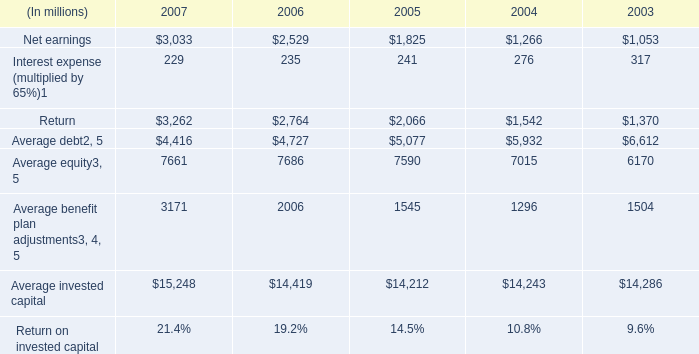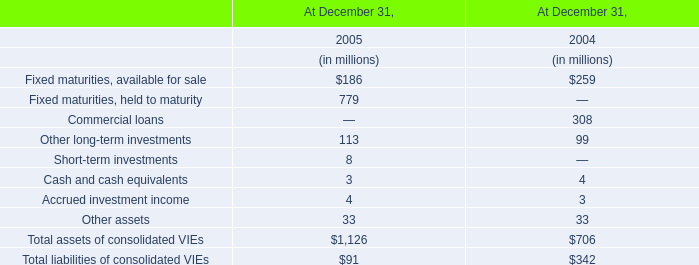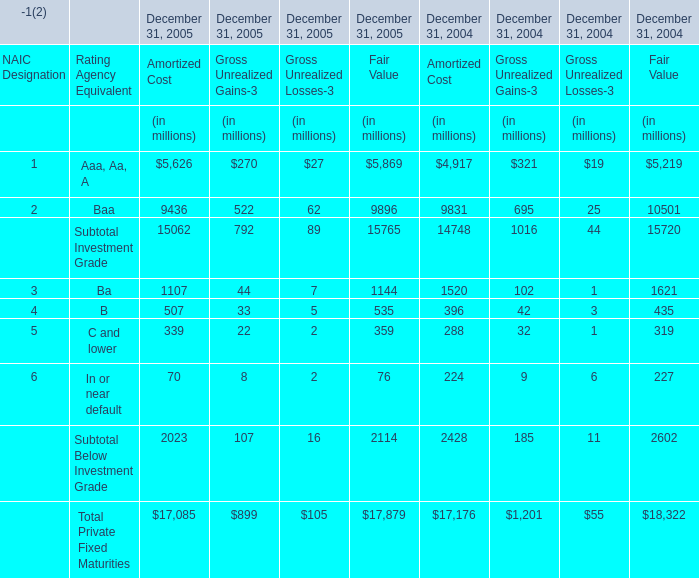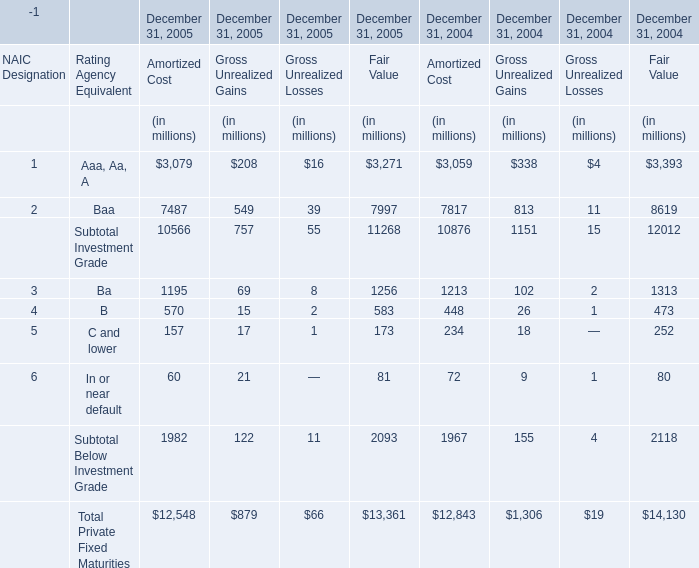What will Aaa, Aa, A for Amortized Cost be like in 2006 if it develops with the same increasing rate as current? (in million) 
Computations: (3079 * (1 + ((3079 - 3059) / 3059)))
Answer: 3099.13076. 